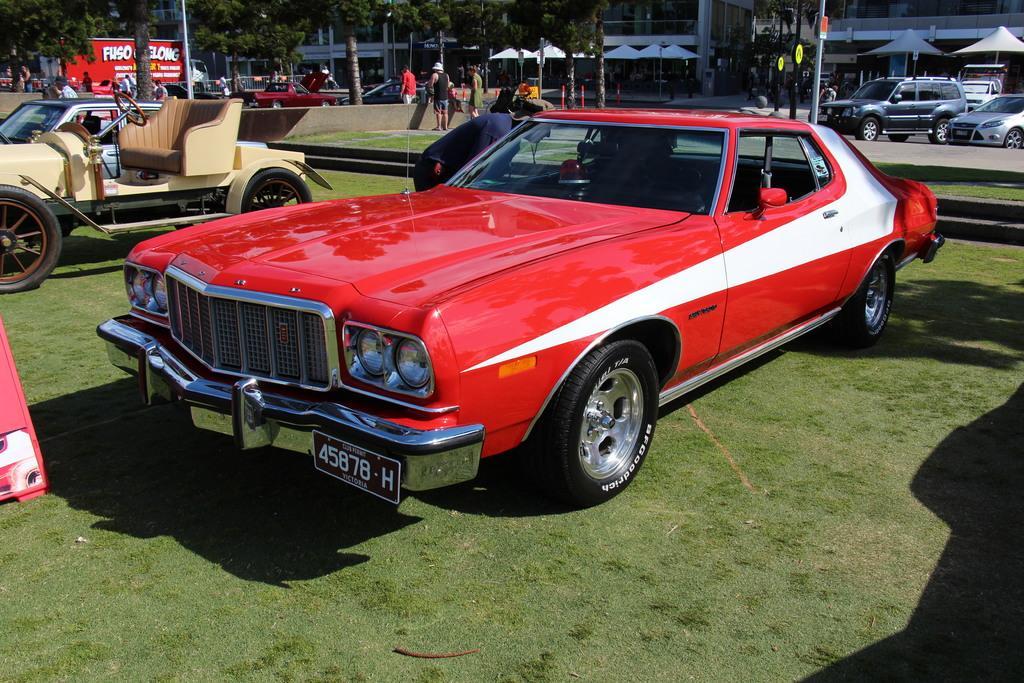Could you give a brief overview of what you see in this image? In this picture there is a car in the center of the image and there are other cars in the top right side of the image, there are trees at the top right side of the image. 